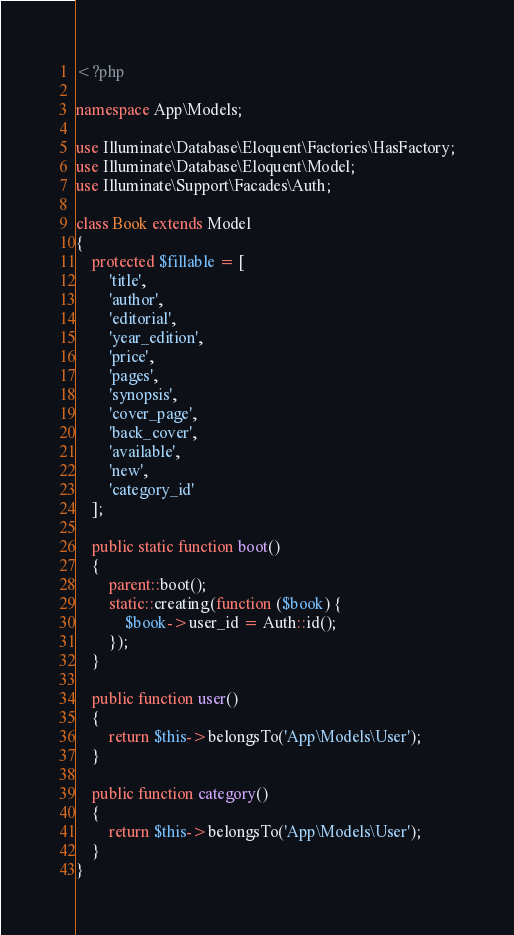<code> <loc_0><loc_0><loc_500><loc_500><_PHP_><?php

namespace App\Models;

use Illuminate\Database\Eloquent\Factories\HasFactory;
use Illuminate\Database\Eloquent\Model;
use Illuminate\Support\Facades\Auth;

class Book extends Model
{
    protected $fillable = [
        'title',
        'author',
        'editorial',
        'year_edition',
        'price',
        'pages',
        'synopsis',
        'cover_page',
        'back_cover',
        'available',
        'new',
        'category_id'
    ];

    public static function boot()
    {
        parent::boot();
        static::creating(function ($book) {
            $book->user_id = Auth::id();
        });
    }

    public function user()
    {
        return $this->belongsTo('App\Models\User');
    }

    public function category()
    {
        return $this->belongsTo('App\Models\User');
    }
}


</code> 